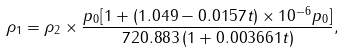Convert formula to latex. <formula><loc_0><loc_0><loc_500><loc_500>\rho _ { 1 } = \rho _ { 2 } \times \frac { p _ { 0 } [ 1 + ( 1 . 0 4 9 - 0 . 0 1 5 7 t ) \times 1 0 ^ { - 6 } p _ { 0 } ] } { 7 2 0 . 8 8 3 \, ( 1 + 0 . 0 0 3 6 6 1 t ) } ,</formula> 